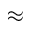<formula> <loc_0><loc_0><loc_500><loc_500>\approx</formula> 